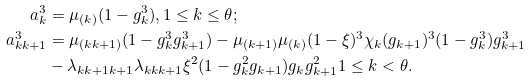<formula> <loc_0><loc_0><loc_500><loc_500>a _ { k } ^ { 3 } & = \mu _ { ( k ) } ( 1 - g _ { k } ^ { 3 } ) , 1 \leq k \leq \theta ; \\ a _ { k k + 1 } ^ { 3 } & = \mu _ { ( k k + 1 ) } ( 1 - g _ { k } ^ { 3 } g _ { k + 1 } ^ { 3 } ) - \mu _ { ( k + 1 ) } \mu _ { ( k ) } ( 1 - \xi ) ^ { 3 } \chi _ { k } ( g _ { k + 1 } ) ^ { 3 } ( 1 - g _ { k } ^ { 3 } ) g _ { k + 1 } ^ { 3 } \\ & - \lambda _ { k k + 1 k + 1 } \lambda _ { k k k + 1 } \xi ^ { 2 } ( 1 - g _ { k } ^ { 2 } g _ { k + 1 } ) g _ { k } g _ { k + 1 } ^ { 2 } 1 \leq k < \theta .</formula> 